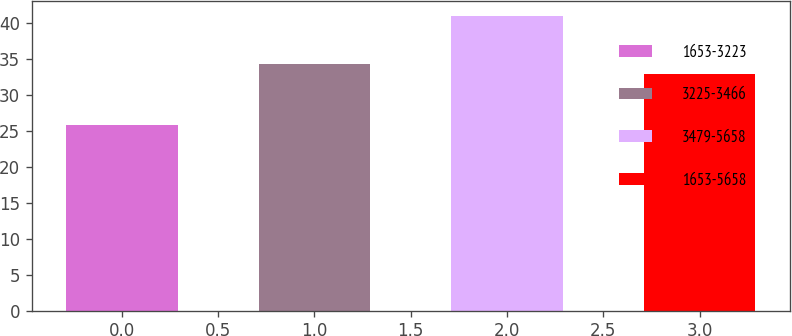<chart> <loc_0><loc_0><loc_500><loc_500><bar_chart><fcel>1653-3223<fcel>3225-3466<fcel>3479-5658<fcel>1653-5658<nl><fcel>25.83<fcel>34.33<fcel>40.96<fcel>32.82<nl></chart> 